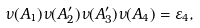<formula> <loc_0><loc_0><loc_500><loc_500>\nu ( A _ { 1 } ) \nu ( A ^ { \prime } _ { 2 } ) \nu ( A ^ { \prime } _ { 3 } ) \nu ( A _ { 4 } ) = \varepsilon _ { 4 } ,</formula> 